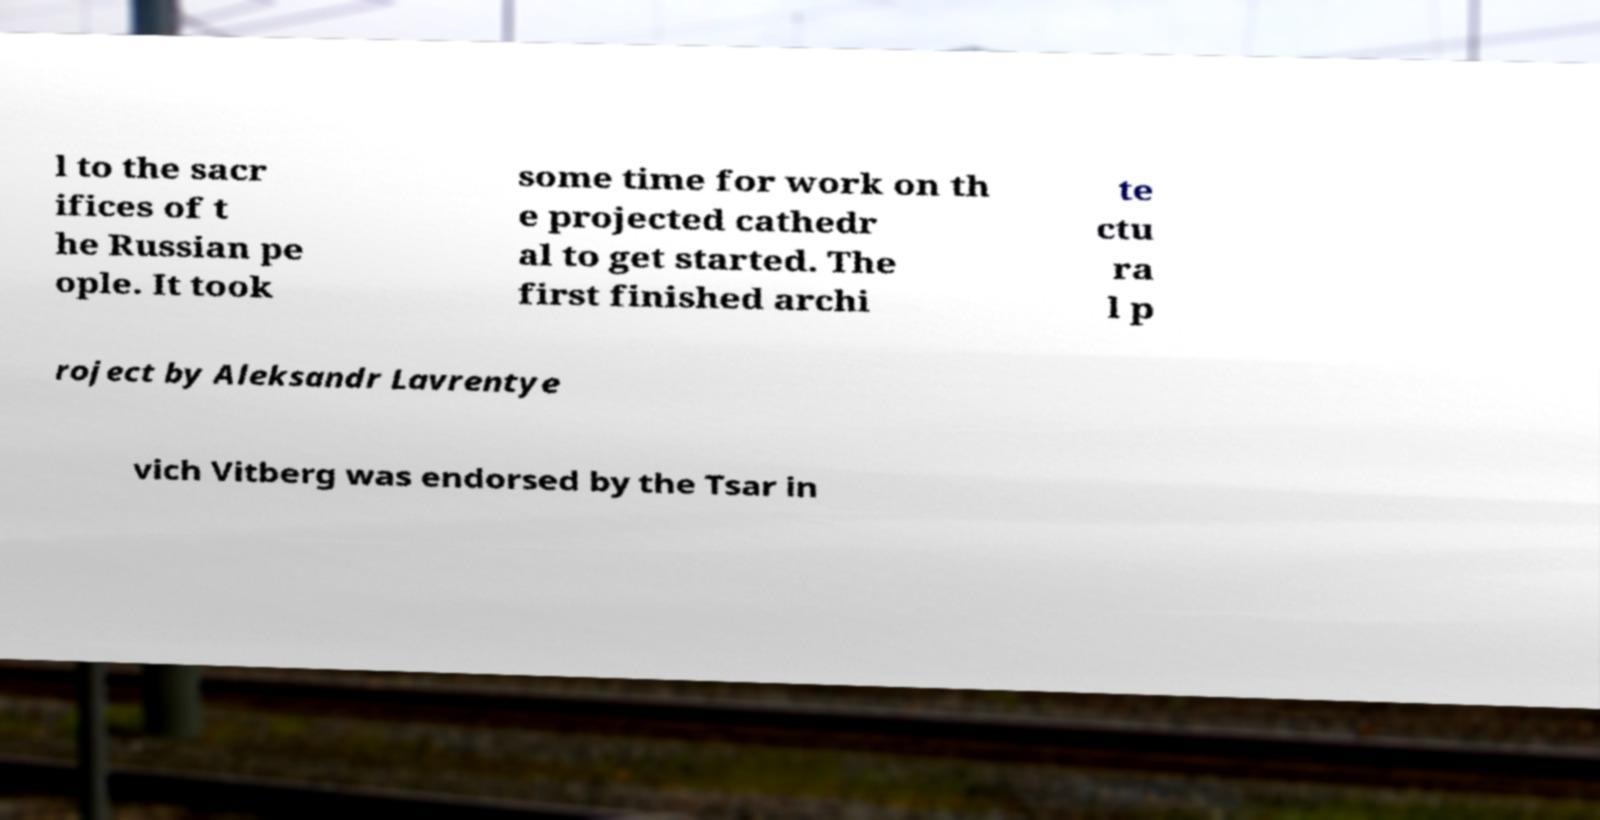Can you accurately transcribe the text from the provided image for me? l to the sacr ifices of t he Russian pe ople. It took some time for work on th e projected cathedr al to get started. The first finished archi te ctu ra l p roject by Aleksandr Lavrentye vich Vitberg was endorsed by the Tsar in 